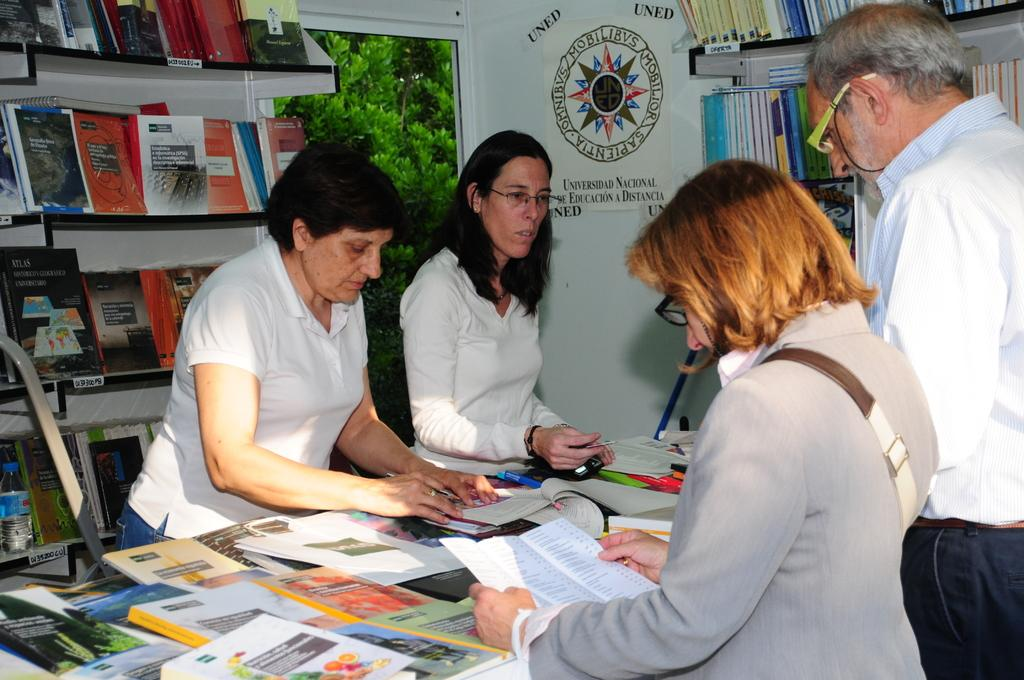<image>
Relay a brief, clear account of the picture shown. Woman looking at a brochure in front of a sign on the wall with UNED on it. 